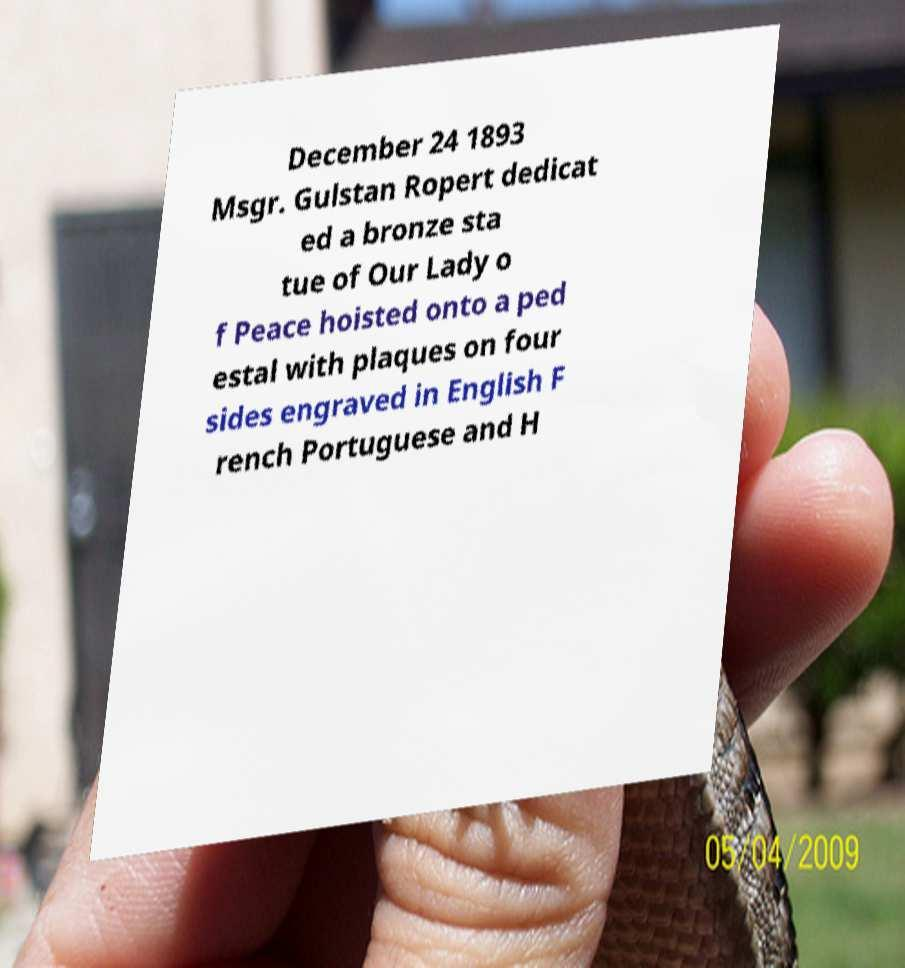Please read and relay the text visible in this image. What does it say? December 24 1893 Msgr. Gulstan Ropert dedicat ed a bronze sta tue of Our Lady o f Peace hoisted onto a ped estal with plaques on four sides engraved in English F rench Portuguese and H 